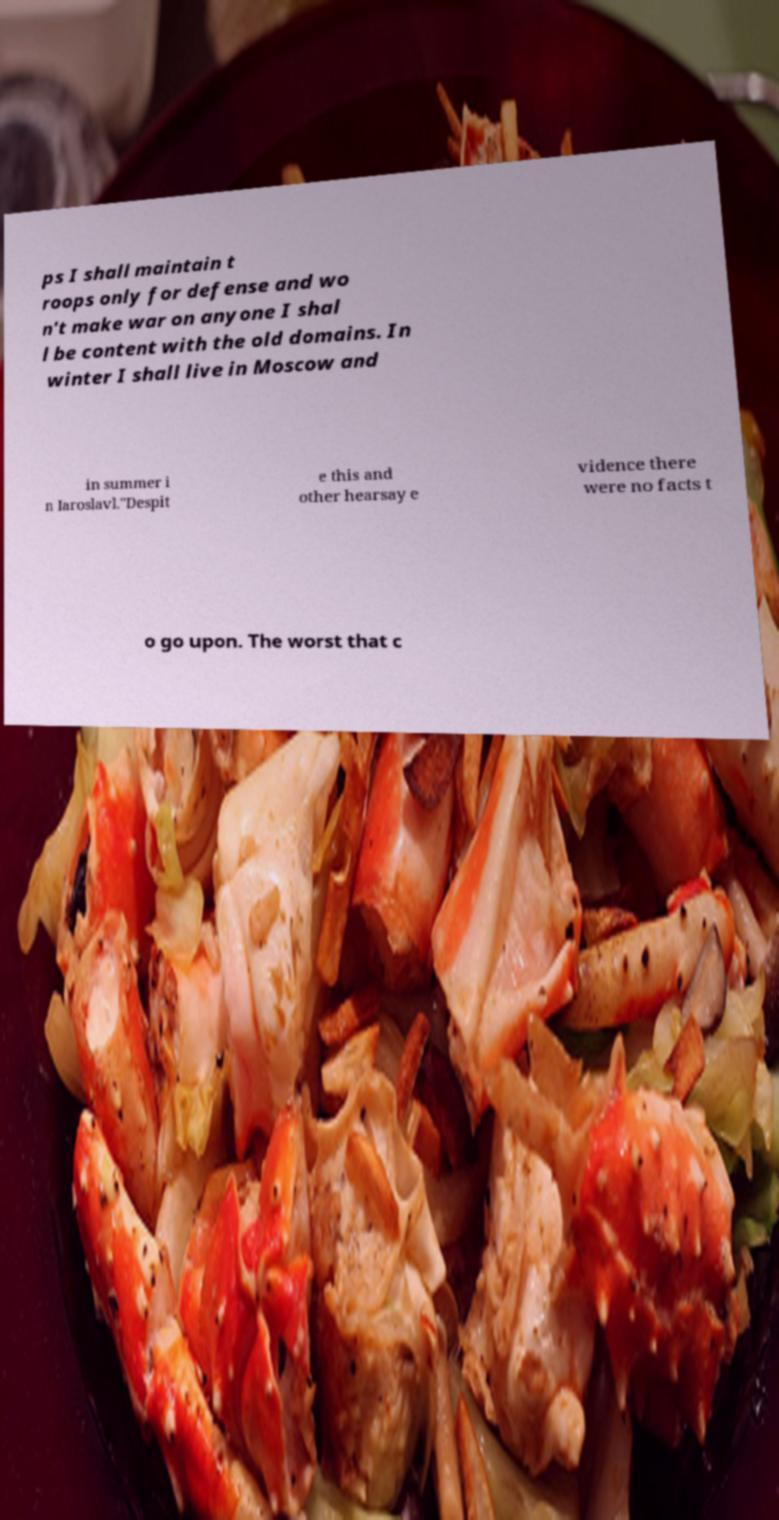Can you read and provide the text displayed in the image?This photo seems to have some interesting text. Can you extract and type it out for me? ps I shall maintain t roops only for defense and wo n't make war on anyone I shal l be content with the old domains. In winter I shall live in Moscow and in summer i n Iaroslavl."Despit e this and other hearsay e vidence there were no facts t o go upon. The worst that c 